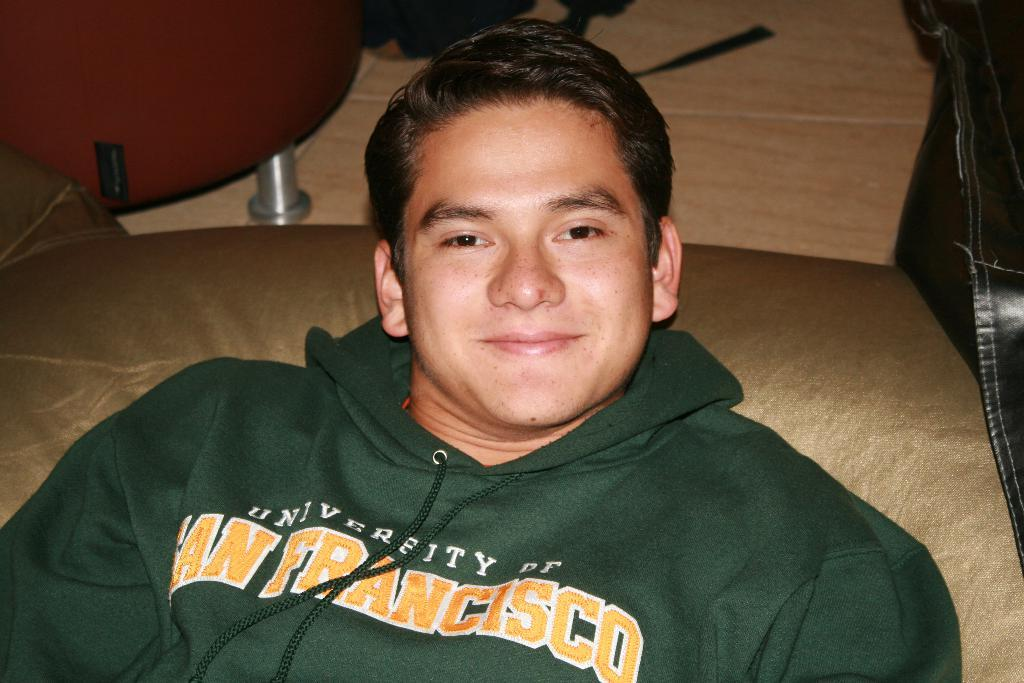<image>
Relay a brief, clear account of the picture shown. A young man wears a green University of San Francisco sweatshirt. 